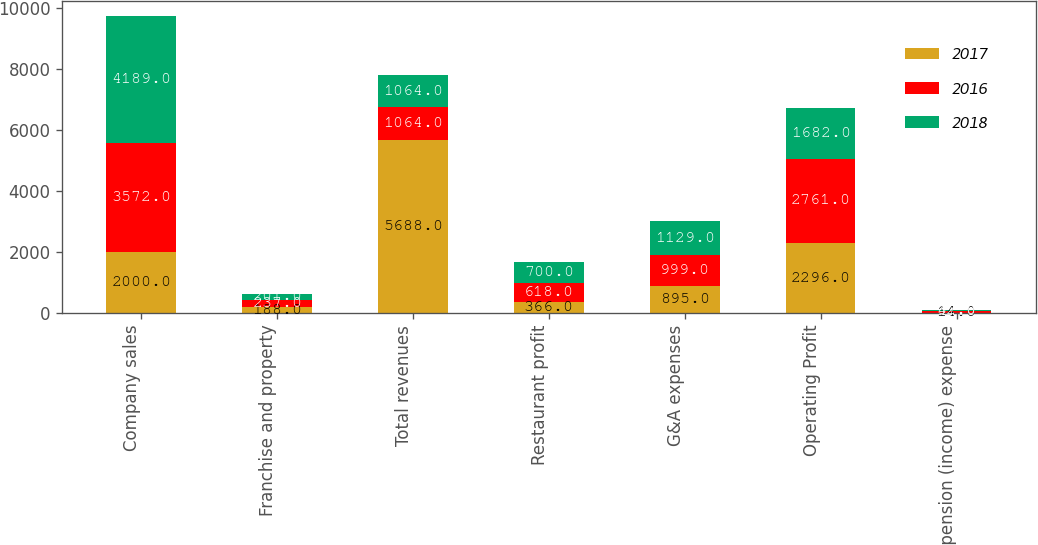<chart> <loc_0><loc_0><loc_500><loc_500><stacked_bar_chart><ecel><fcel>Company sales<fcel>Franchise and property<fcel>Total revenues<fcel>Restaurant profit<fcel>G&A expenses<fcel>Operating Profit<fcel>Other pension (income) expense<nl><fcel>2017<fcel>2000<fcel>188<fcel>5688<fcel>366<fcel>895<fcel>2296<fcel>14<nl><fcel>2016<fcel>3572<fcel>237<fcel>1064<fcel>618<fcel>999<fcel>2761<fcel>47<nl><fcel>2018<fcel>4189<fcel>201<fcel>1064<fcel>700<fcel>1129<fcel>1682<fcel>32<nl></chart> 